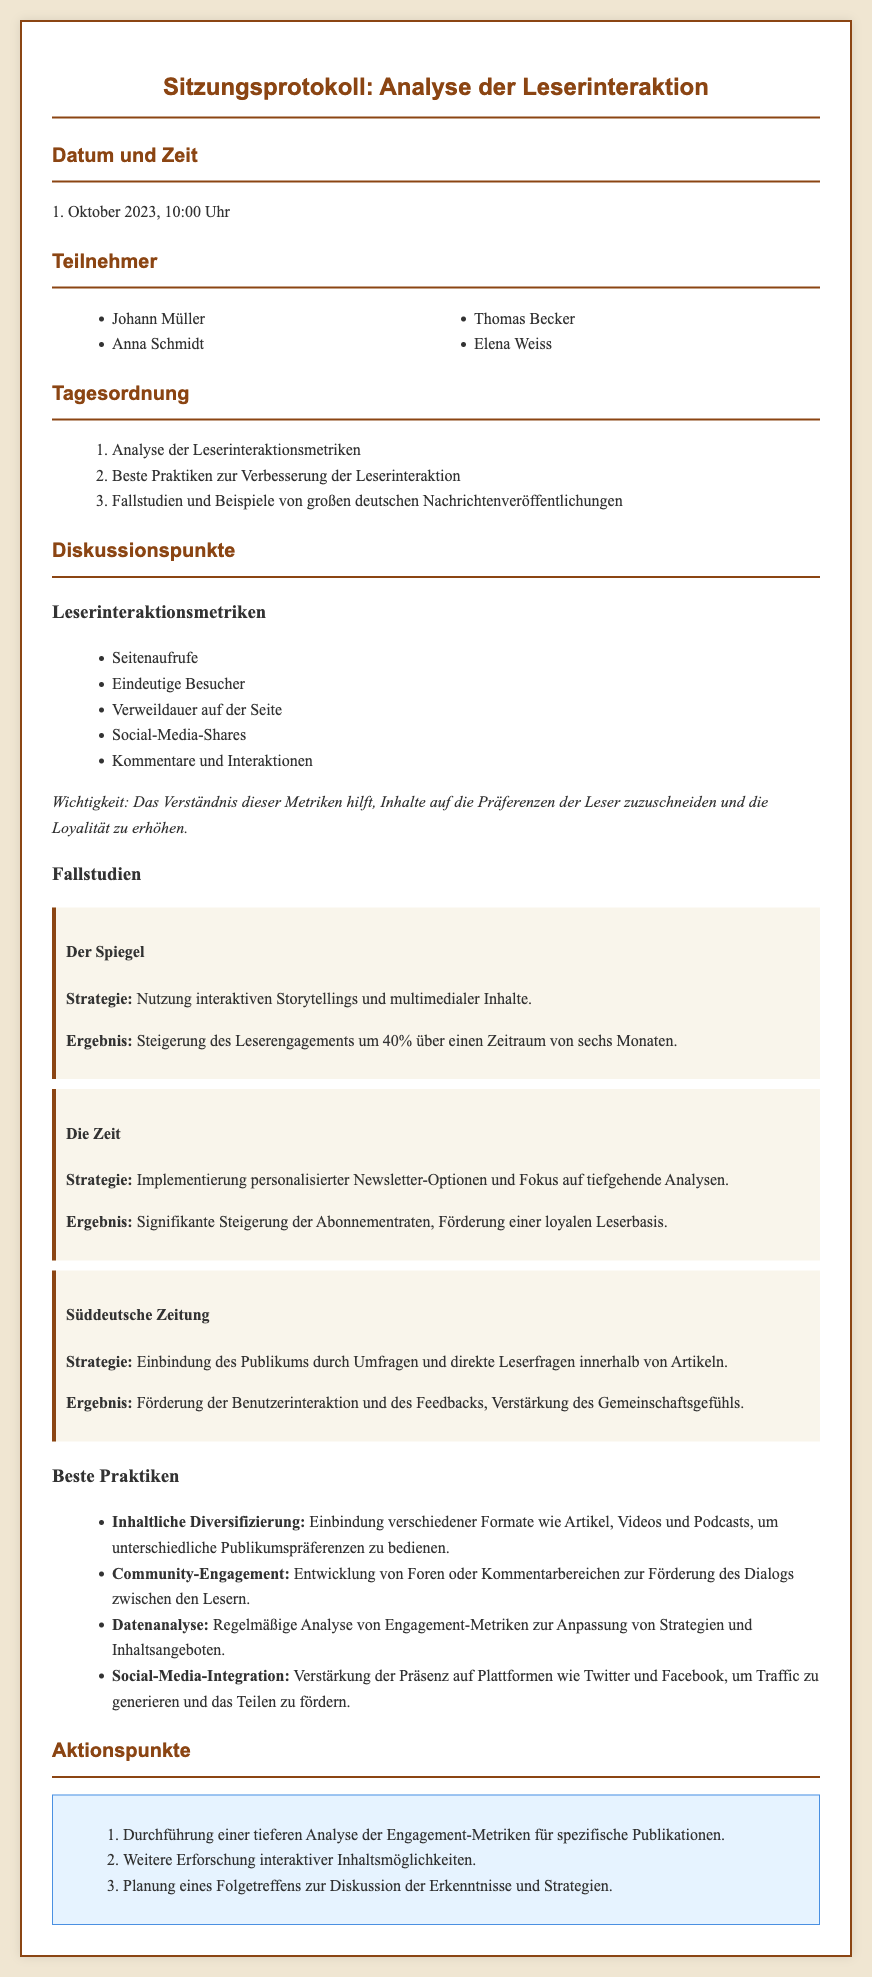Was ist das Datum und die Uhrzeit der Sitzung? Das Datum und die Uhrzeit sind am Anfang des Dokuments angegeben.
Answer: 1. Oktober 2023, 10:00 Uhr Wer waren die Teilnehmer der Sitzung? Die Teilnehmer sind in einer Liste im Dokument aufgeführt.
Answer: Johann Müller, Anna Schmidt, Thomas Becker, Elena Weiss Welche Metriken wurden zur Leserinteraktion analysiert? Die Metriken sind im Abschnitt über Leserinteraktionsmetriken aufgelistet.
Answer: Seitenaufrufe, Eindeutige Besucher, Verweildauer auf der Seite, Social-Media-Shares, Kommentare und Interaktionen Welches Ergebnis erzielte „Der Spiegel“ bei der Steigerung des Leserengagements? Das Ergebnis wird im Abschnitt über Fallstudien genannt.
Answer: 40% Was ist eine der besten Praktiken zur Verbesserung der Leserinteraktion? Die besten Praktiken sind im entsprechenden Abschnitt zusammengefasst.
Answer: Inhaltliche Diversifizierung Welche Strategie wurde von der „Süddeutschen Zeitung“ verwendet? Die Strategie wird im Abschnitt über Fallstudien erwähnt.
Answer: Einbindung des Publikums durch Umfragen und direkte Leserfragen Wie viele Aktionspunkte wurden festgelegt? Die Anzahl der Aktionspunkte ist im Abschnitt über Aktionspunkte zu finden.
Answer: 3 